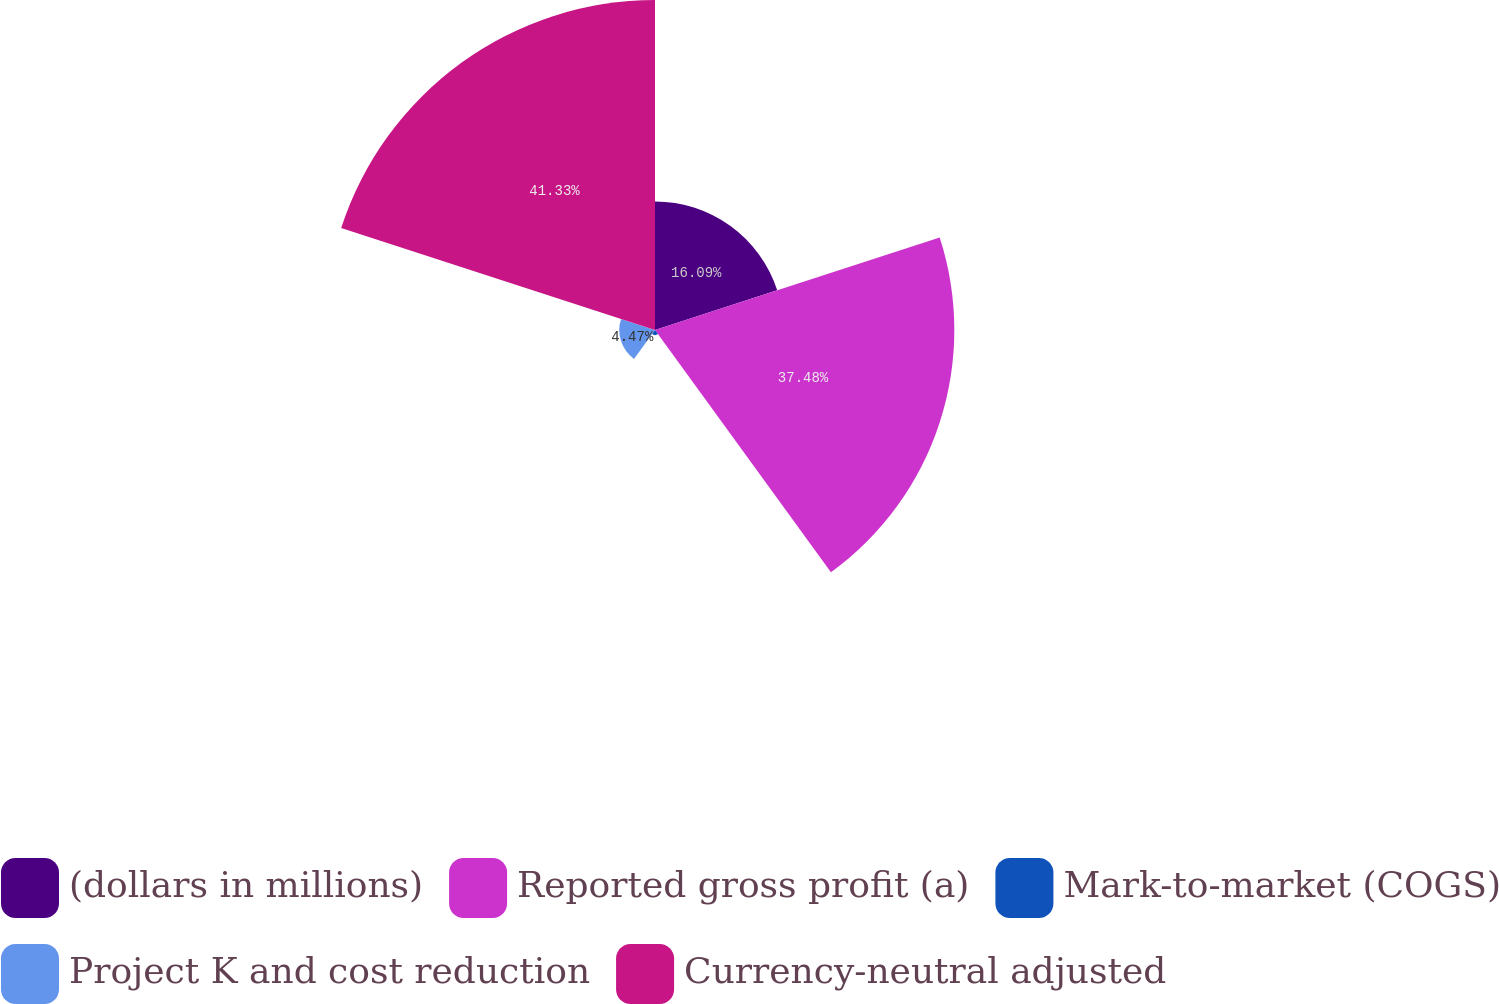<chart> <loc_0><loc_0><loc_500><loc_500><pie_chart><fcel>(dollars in millions)<fcel>Reported gross profit (a)<fcel>Mark-to-market (COGS)<fcel>Project K and cost reduction<fcel>Currency-neutral adjusted<nl><fcel>16.09%<fcel>37.48%<fcel>0.63%<fcel>4.47%<fcel>41.32%<nl></chart> 